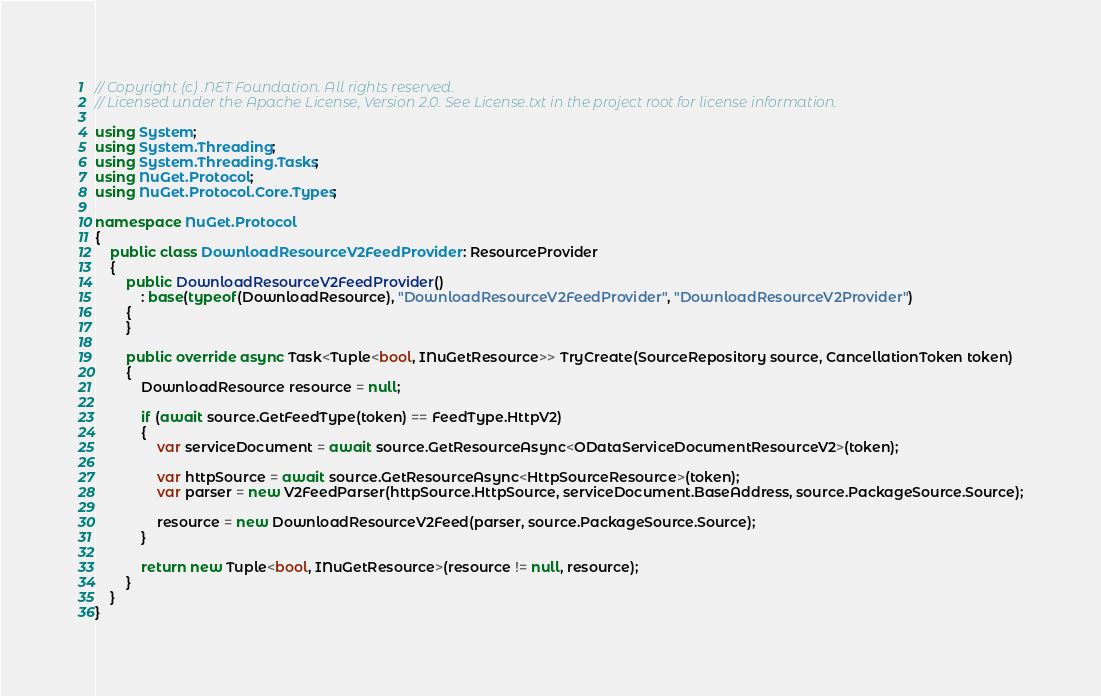Convert code to text. <code><loc_0><loc_0><loc_500><loc_500><_C#_>// Copyright (c) .NET Foundation. All rights reserved.
// Licensed under the Apache License, Version 2.0. See License.txt in the project root for license information.

using System;
using System.Threading;
using System.Threading.Tasks;
using NuGet.Protocol;
using NuGet.Protocol.Core.Types;

namespace NuGet.Protocol
{
    public class DownloadResourceV2FeedProvider : ResourceProvider
    {
        public DownloadResourceV2FeedProvider()
            : base(typeof(DownloadResource), "DownloadResourceV2FeedProvider", "DownloadResourceV2Provider")
        {
        }

        public override async Task<Tuple<bool, INuGetResource>> TryCreate(SourceRepository source, CancellationToken token)
        {
            DownloadResource resource = null;

            if (await source.GetFeedType(token) == FeedType.HttpV2)
            {
                var serviceDocument = await source.GetResourceAsync<ODataServiceDocumentResourceV2>(token);

                var httpSource = await source.GetResourceAsync<HttpSourceResource>(token);
                var parser = new V2FeedParser(httpSource.HttpSource, serviceDocument.BaseAddress, source.PackageSource.Source);

                resource = new DownloadResourceV2Feed(parser, source.PackageSource.Source);
            }

            return new Tuple<bool, INuGetResource>(resource != null, resource);
        }
    }
}
</code> 